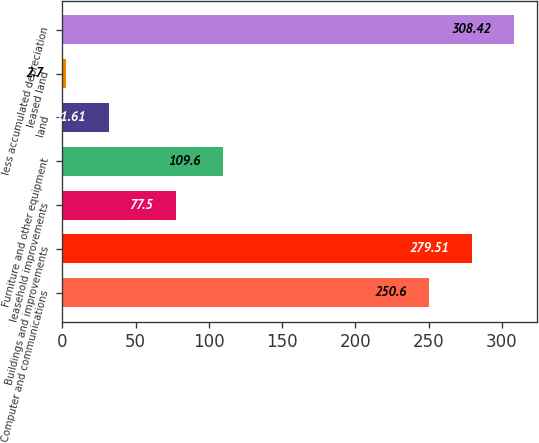<chart> <loc_0><loc_0><loc_500><loc_500><bar_chart><fcel>Computer and communications<fcel>Buildings and improvements<fcel>leasehold improvements<fcel>Furniture and other equipment<fcel>land<fcel>leased land<fcel>less accumulated depreciation<nl><fcel>250.6<fcel>279.51<fcel>77.5<fcel>109.6<fcel>31.61<fcel>2.7<fcel>308.42<nl></chart> 